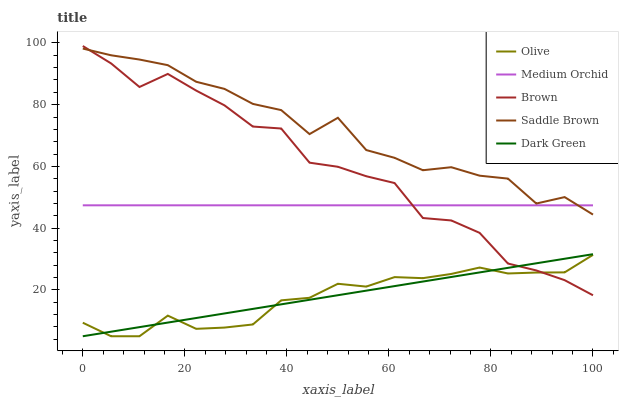Does Olive have the minimum area under the curve?
Answer yes or no. Yes. Does Saddle Brown have the maximum area under the curve?
Answer yes or no. Yes. Does Brown have the minimum area under the curve?
Answer yes or no. No. Does Brown have the maximum area under the curve?
Answer yes or no. No. Is Dark Green the smoothest?
Answer yes or no. Yes. Is Brown the roughest?
Answer yes or no. Yes. Is Medium Orchid the smoothest?
Answer yes or no. No. Is Medium Orchid the roughest?
Answer yes or no. No. Does Olive have the lowest value?
Answer yes or no. Yes. Does Brown have the lowest value?
Answer yes or no. No. Does Brown have the highest value?
Answer yes or no. Yes. Does Medium Orchid have the highest value?
Answer yes or no. No. Is Dark Green less than Medium Orchid?
Answer yes or no. Yes. Is Medium Orchid greater than Dark Green?
Answer yes or no. Yes. Does Olive intersect Brown?
Answer yes or no. Yes. Is Olive less than Brown?
Answer yes or no. No. Is Olive greater than Brown?
Answer yes or no. No. Does Dark Green intersect Medium Orchid?
Answer yes or no. No. 